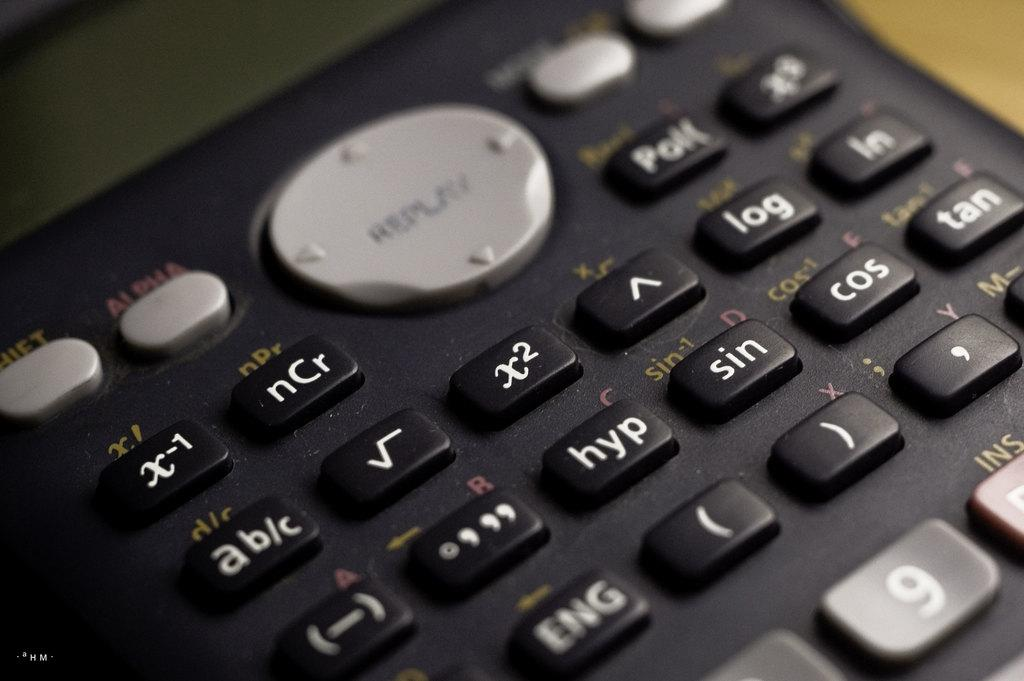<image>
Render a clear and concise summary of the photo. Calculator with a large button that says REPLAY on it. 